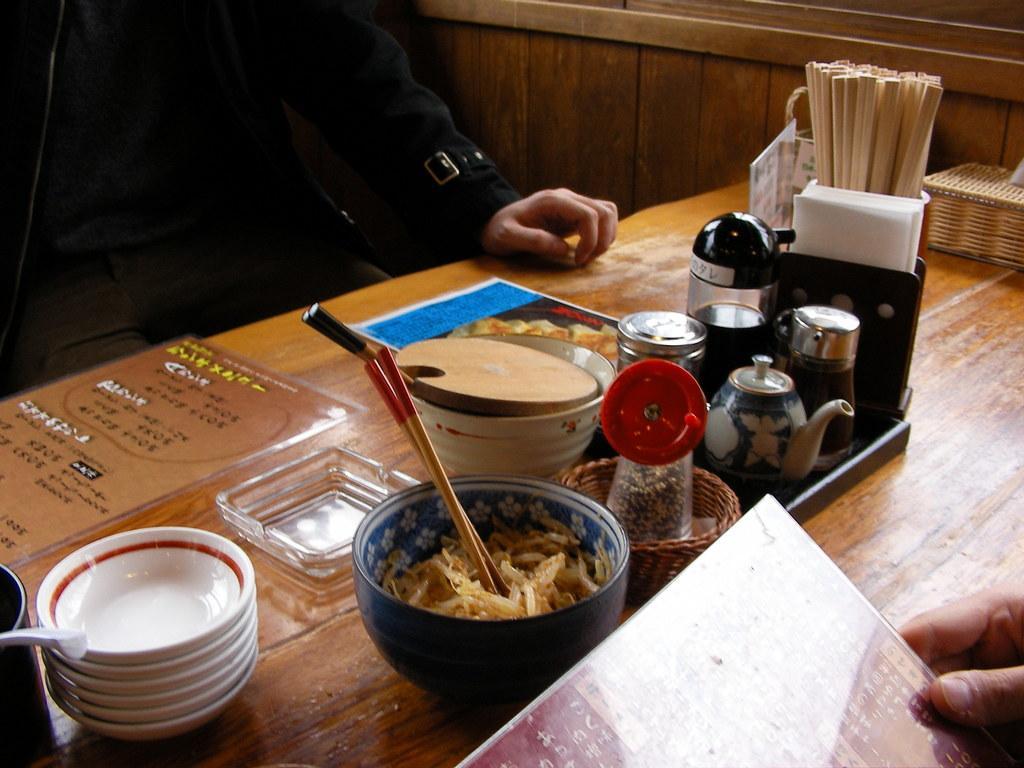Can you describe this image briefly? The picture is clicked inside a Chinese restaurant where food items , plates are on top of it. To the right side of the image there are tissues and chopsticks placed. There are two people sitting on the table. 